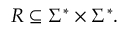Convert formula to latex. <formula><loc_0><loc_0><loc_500><loc_500>R \subseteq \Sigma ^ { * } \times \Sigma ^ { * } .</formula> 